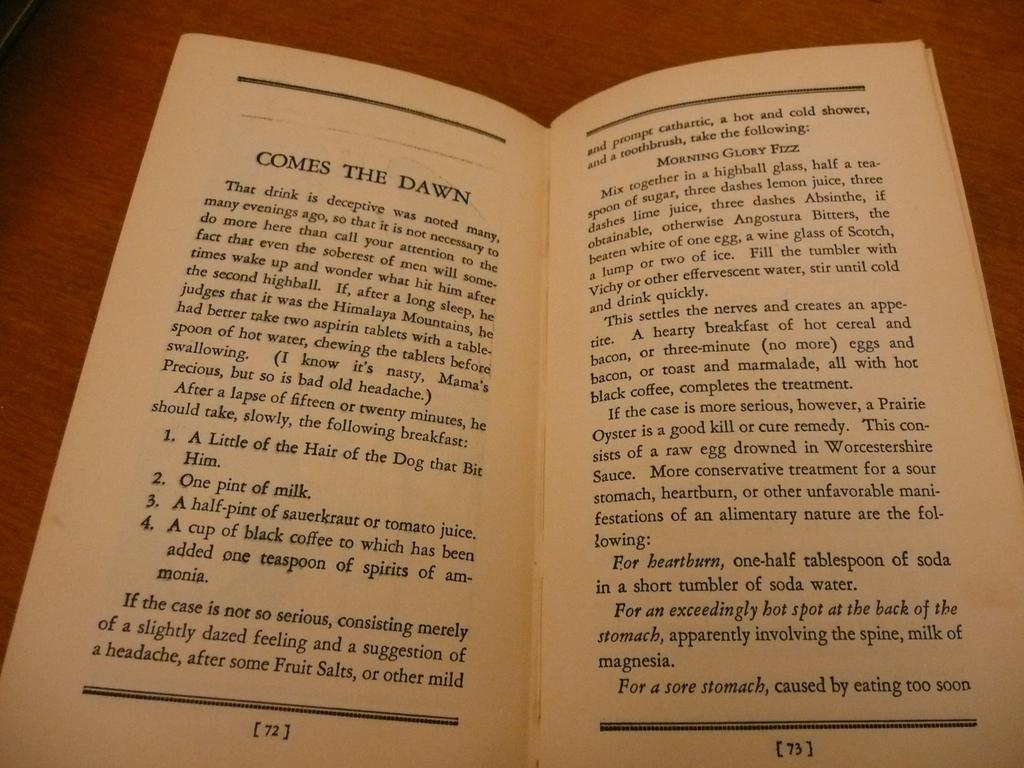<image>
Summarize the visual content of the image. The man could have One pint of milk for breakfast. 